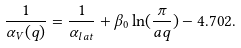<formula> <loc_0><loc_0><loc_500><loc_500>\frac { 1 } { \alpha _ { V } ( q ) } = \frac { 1 } { \alpha _ { l a t } } + \beta _ { 0 } \ln ( \frac { \pi } { a q } ) - 4 . 7 0 2 .</formula> 